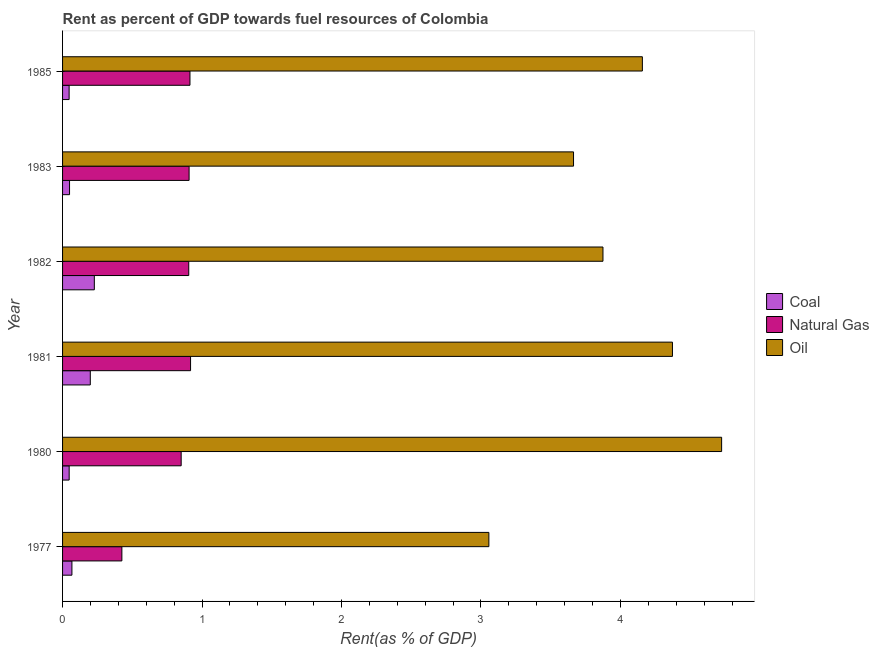How many different coloured bars are there?
Provide a short and direct response. 3. How many bars are there on the 4th tick from the top?
Keep it short and to the point. 3. In how many cases, is the number of bars for a given year not equal to the number of legend labels?
Keep it short and to the point. 0. What is the rent towards natural gas in 1981?
Provide a succinct answer. 0.92. Across all years, what is the maximum rent towards natural gas?
Your answer should be very brief. 0.92. Across all years, what is the minimum rent towards oil?
Offer a very short reply. 3.06. In which year was the rent towards oil minimum?
Provide a short and direct response. 1977. What is the total rent towards coal in the graph?
Your response must be concise. 0.64. What is the difference between the rent towards oil in 1980 and that in 1983?
Ensure brevity in your answer.  1.06. What is the difference between the rent towards oil in 1983 and the rent towards natural gas in 1980?
Offer a very short reply. 2.81. What is the average rent towards natural gas per year?
Your response must be concise. 0.82. In the year 1977, what is the difference between the rent towards oil and rent towards coal?
Provide a short and direct response. 2.99. In how many years, is the rent towards oil greater than 2.6 %?
Provide a succinct answer. 6. What is the ratio of the rent towards oil in 1981 to that in 1985?
Your answer should be compact. 1.05. Is the rent towards oil in 1983 less than that in 1985?
Give a very brief answer. Yes. What is the difference between the highest and the second highest rent towards coal?
Offer a very short reply. 0.03. What is the difference between the highest and the lowest rent towards natural gas?
Offer a very short reply. 0.49. Is the sum of the rent towards coal in 1980 and 1981 greater than the maximum rent towards natural gas across all years?
Offer a very short reply. No. What does the 1st bar from the top in 1977 represents?
Make the answer very short. Oil. What does the 1st bar from the bottom in 1980 represents?
Give a very brief answer. Coal. How many bars are there?
Your answer should be very brief. 18. Are all the bars in the graph horizontal?
Keep it short and to the point. Yes. How many years are there in the graph?
Your answer should be compact. 6. What is the difference between two consecutive major ticks on the X-axis?
Keep it short and to the point. 1. Does the graph contain grids?
Offer a very short reply. No. Where does the legend appear in the graph?
Keep it short and to the point. Center right. How many legend labels are there?
Offer a very short reply. 3. What is the title of the graph?
Your response must be concise. Rent as percent of GDP towards fuel resources of Colombia. What is the label or title of the X-axis?
Provide a succinct answer. Rent(as % of GDP). What is the Rent(as % of GDP) of Coal in 1977?
Make the answer very short. 0.07. What is the Rent(as % of GDP) in Natural Gas in 1977?
Offer a terse response. 0.43. What is the Rent(as % of GDP) of Oil in 1977?
Give a very brief answer. 3.06. What is the Rent(as % of GDP) in Coal in 1980?
Ensure brevity in your answer.  0.05. What is the Rent(as % of GDP) in Natural Gas in 1980?
Offer a terse response. 0.85. What is the Rent(as % of GDP) of Oil in 1980?
Ensure brevity in your answer.  4.73. What is the Rent(as % of GDP) of Coal in 1981?
Make the answer very short. 0.2. What is the Rent(as % of GDP) in Natural Gas in 1981?
Make the answer very short. 0.92. What is the Rent(as % of GDP) of Oil in 1981?
Make the answer very short. 4.37. What is the Rent(as % of GDP) of Coal in 1982?
Ensure brevity in your answer.  0.23. What is the Rent(as % of GDP) of Natural Gas in 1982?
Ensure brevity in your answer.  0.9. What is the Rent(as % of GDP) in Oil in 1982?
Provide a succinct answer. 3.87. What is the Rent(as % of GDP) in Coal in 1983?
Your answer should be very brief. 0.05. What is the Rent(as % of GDP) in Natural Gas in 1983?
Provide a short and direct response. 0.91. What is the Rent(as % of GDP) of Oil in 1983?
Your answer should be compact. 3.66. What is the Rent(as % of GDP) of Coal in 1985?
Make the answer very short. 0.05. What is the Rent(as % of GDP) in Natural Gas in 1985?
Ensure brevity in your answer.  0.91. What is the Rent(as % of GDP) of Oil in 1985?
Ensure brevity in your answer.  4.16. Across all years, what is the maximum Rent(as % of GDP) of Coal?
Your answer should be very brief. 0.23. Across all years, what is the maximum Rent(as % of GDP) of Natural Gas?
Your response must be concise. 0.92. Across all years, what is the maximum Rent(as % of GDP) in Oil?
Offer a terse response. 4.73. Across all years, what is the minimum Rent(as % of GDP) of Coal?
Offer a terse response. 0.05. Across all years, what is the minimum Rent(as % of GDP) in Natural Gas?
Your response must be concise. 0.43. Across all years, what is the minimum Rent(as % of GDP) in Oil?
Your response must be concise. 3.06. What is the total Rent(as % of GDP) of Coal in the graph?
Your answer should be very brief. 0.64. What is the total Rent(as % of GDP) in Natural Gas in the graph?
Your answer should be very brief. 4.92. What is the total Rent(as % of GDP) of Oil in the graph?
Offer a very short reply. 23.85. What is the difference between the Rent(as % of GDP) of Coal in 1977 and that in 1980?
Provide a succinct answer. 0.02. What is the difference between the Rent(as % of GDP) of Natural Gas in 1977 and that in 1980?
Keep it short and to the point. -0.43. What is the difference between the Rent(as % of GDP) of Oil in 1977 and that in 1980?
Provide a succinct answer. -1.67. What is the difference between the Rent(as % of GDP) in Coal in 1977 and that in 1981?
Make the answer very short. -0.13. What is the difference between the Rent(as % of GDP) in Natural Gas in 1977 and that in 1981?
Provide a succinct answer. -0.49. What is the difference between the Rent(as % of GDP) in Oil in 1977 and that in 1981?
Provide a succinct answer. -1.32. What is the difference between the Rent(as % of GDP) of Coal in 1977 and that in 1982?
Your answer should be very brief. -0.16. What is the difference between the Rent(as % of GDP) of Natural Gas in 1977 and that in 1982?
Give a very brief answer. -0.48. What is the difference between the Rent(as % of GDP) in Oil in 1977 and that in 1982?
Make the answer very short. -0.82. What is the difference between the Rent(as % of GDP) in Coal in 1977 and that in 1983?
Keep it short and to the point. 0.02. What is the difference between the Rent(as % of GDP) of Natural Gas in 1977 and that in 1983?
Ensure brevity in your answer.  -0.48. What is the difference between the Rent(as % of GDP) of Oil in 1977 and that in 1983?
Provide a succinct answer. -0.61. What is the difference between the Rent(as % of GDP) in Coal in 1977 and that in 1985?
Offer a terse response. 0.02. What is the difference between the Rent(as % of GDP) of Natural Gas in 1977 and that in 1985?
Your response must be concise. -0.49. What is the difference between the Rent(as % of GDP) in Oil in 1977 and that in 1985?
Your answer should be very brief. -1.1. What is the difference between the Rent(as % of GDP) in Coal in 1980 and that in 1981?
Provide a succinct answer. -0.15. What is the difference between the Rent(as % of GDP) of Natural Gas in 1980 and that in 1981?
Ensure brevity in your answer.  -0.07. What is the difference between the Rent(as % of GDP) in Oil in 1980 and that in 1981?
Your answer should be compact. 0.35. What is the difference between the Rent(as % of GDP) in Coal in 1980 and that in 1982?
Make the answer very short. -0.18. What is the difference between the Rent(as % of GDP) in Natural Gas in 1980 and that in 1982?
Your answer should be very brief. -0.05. What is the difference between the Rent(as % of GDP) in Oil in 1980 and that in 1982?
Your answer should be very brief. 0.85. What is the difference between the Rent(as % of GDP) of Coal in 1980 and that in 1983?
Provide a short and direct response. -0. What is the difference between the Rent(as % of GDP) in Natural Gas in 1980 and that in 1983?
Offer a terse response. -0.06. What is the difference between the Rent(as % of GDP) in Oil in 1980 and that in 1983?
Provide a short and direct response. 1.06. What is the difference between the Rent(as % of GDP) in Natural Gas in 1980 and that in 1985?
Make the answer very short. -0.06. What is the difference between the Rent(as % of GDP) in Oil in 1980 and that in 1985?
Give a very brief answer. 0.57. What is the difference between the Rent(as % of GDP) in Coal in 1981 and that in 1982?
Give a very brief answer. -0.03. What is the difference between the Rent(as % of GDP) of Natural Gas in 1981 and that in 1982?
Offer a terse response. 0.01. What is the difference between the Rent(as % of GDP) of Oil in 1981 and that in 1982?
Provide a succinct answer. 0.5. What is the difference between the Rent(as % of GDP) of Coal in 1981 and that in 1983?
Provide a short and direct response. 0.15. What is the difference between the Rent(as % of GDP) in Natural Gas in 1981 and that in 1983?
Offer a very short reply. 0.01. What is the difference between the Rent(as % of GDP) in Oil in 1981 and that in 1983?
Your response must be concise. 0.71. What is the difference between the Rent(as % of GDP) of Coal in 1981 and that in 1985?
Provide a succinct answer. 0.15. What is the difference between the Rent(as % of GDP) in Natural Gas in 1981 and that in 1985?
Provide a short and direct response. 0. What is the difference between the Rent(as % of GDP) in Oil in 1981 and that in 1985?
Offer a terse response. 0.22. What is the difference between the Rent(as % of GDP) in Coal in 1982 and that in 1983?
Provide a succinct answer. 0.18. What is the difference between the Rent(as % of GDP) of Natural Gas in 1982 and that in 1983?
Provide a short and direct response. -0. What is the difference between the Rent(as % of GDP) of Oil in 1982 and that in 1983?
Offer a very short reply. 0.21. What is the difference between the Rent(as % of GDP) of Coal in 1982 and that in 1985?
Make the answer very short. 0.18. What is the difference between the Rent(as % of GDP) in Natural Gas in 1982 and that in 1985?
Ensure brevity in your answer.  -0.01. What is the difference between the Rent(as % of GDP) of Oil in 1982 and that in 1985?
Offer a terse response. -0.28. What is the difference between the Rent(as % of GDP) in Coal in 1983 and that in 1985?
Give a very brief answer. 0. What is the difference between the Rent(as % of GDP) in Natural Gas in 1983 and that in 1985?
Provide a succinct answer. -0.01. What is the difference between the Rent(as % of GDP) of Oil in 1983 and that in 1985?
Offer a terse response. -0.49. What is the difference between the Rent(as % of GDP) in Coal in 1977 and the Rent(as % of GDP) in Natural Gas in 1980?
Give a very brief answer. -0.78. What is the difference between the Rent(as % of GDP) of Coal in 1977 and the Rent(as % of GDP) of Oil in 1980?
Make the answer very short. -4.66. What is the difference between the Rent(as % of GDP) in Natural Gas in 1977 and the Rent(as % of GDP) in Oil in 1980?
Provide a succinct answer. -4.3. What is the difference between the Rent(as % of GDP) in Coal in 1977 and the Rent(as % of GDP) in Natural Gas in 1981?
Make the answer very short. -0.85. What is the difference between the Rent(as % of GDP) in Coal in 1977 and the Rent(as % of GDP) in Oil in 1981?
Give a very brief answer. -4.31. What is the difference between the Rent(as % of GDP) of Natural Gas in 1977 and the Rent(as % of GDP) of Oil in 1981?
Keep it short and to the point. -3.95. What is the difference between the Rent(as % of GDP) in Coal in 1977 and the Rent(as % of GDP) in Natural Gas in 1982?
Ensure brevity in your answer.  -0.84. What is the difference between the Rent(as % of GDP) of Coal in 1977 and the Rent(as % of GDP) of Oil in 1982?
Your answer should be compact. -3.81. What is the difference between the Rent(as % of GDP) in Natural Gas in 1977 and the Rent(as % of GDP) in Oil in 1982?
Your response must be concise. -3.45. What is the difference between the Rent(as % of GDP) of Coal in 1977 and the Rent(as % of GDP) of Natural Gas in 1983?
Keep it short and to the point. -0.84. What is the difference between the Rent(as % of GDP) of Coal in 1977 and the Rent(as % of GDP) of Oil in 1983?
Provide a short and direct response. -3.6. What is the difference between the Rent(as % of GDP) in Natural Gas in 1977 and the Rent(as % of GDP) in Oil in 1983?
Your answer should be compact. -3.24. What is the difference between the Rent(as % of GDP) of Coal in 1977 and the Rent(as % of GDP) of Natural Gas in 1985?
Offer a terse response. -0.85. What is the difference between the Rent(as % of GDP) in Coal in 1977 and the Rent(as % of GDP) in Oil in 1985?
Offer a very short reply. -4.09. What is the difference between the Rent(as % of GDP) of Natural Gas in 1977 and the Rent(as % of GDP) of Oil in 1985?
Your answer should be compact. -3.73. What is the difference between the Rent(as % of GDP) in Coal in 1980 and the Rent(as % of GDP) in Natural Gas in 1981?
Offer a very short reply. -0.87. What is the difference between the Rent(as % of GDP) in Coal in 1980 and the Rent(as % of GDP) in Oil in 1981?
Provide a succinct answer. -4.33. What is the difference between the Rent(as % of GDP) in Natural Gas in 1980 and the Rent(as % of GDP) in Oil in 1981?
Provide a succinct answer. -3.52. What is the difference between the Rent(as % of GDP) of Coal in 1980 and the Rent(as % of GDP) of Natural Gas in 1982?
Keep it short and to the point. -0.86. What is the difference between the Rent(as % of GDP) in Coal in 1980 and the Rent(as % of GDP) in Oil in 1982?
Give a very brief answer. -3.83. What is the difference between the Rent(as % of GDP) in Natural Gas in 1980 and the Rent(as % of GDP) in Oil in 1982?
Offer a terse response. -3.02. What is the difference between the Rent(as % of GDP) of Coal in 1980 and the Rent(as % of GDP) of Natural Gas in 1983?
Offer a very short reply. -0.86. What is the difference between the Rent(as % of GDP) of Coal in 1980 and the Rent(as % of GDP) of Oil in 1983?
Keep it short and to the point. -3.62. What is the difference between the Rent(as % of GDP) of Natural Gas in 1980 and the Rent(as % of GDP) of Oil in 1983?
Keep it short and to the point. -2.81. What is the difference between the Rent(as % of GDP) in Coal in 1980 and the Rent(as % of GDP) in Natural Gas in 1985?
Provide a succinct answer. -0.87. What is the difference between the Rent(as % of GDP) in Coal in 1980 and the Rent(as % of GDP) in Oil in 1985?
Your answer should be compact. -4.11. What is the difference between the Rent(as % of GDP) in Natural Gas in 1980 and the Rent(as % of GDP) in Oil in 1985?
Make the answer very short. -3.31. What is the difference between the Rent(as % of GDP) in Coal in 1981 and the Rent(as % of GDP) in Natural Gas in 1982?
Your answer should be very brief. -0.71. What is the difference between the Rent(as % of GDP) of Coal in 1981 and the Rent(as % of GDP) of Oil in 1982?
Ensure brevity in your answer.  -3.68. What is the difference between the Rent(as % of GDP) of Natural Gas in 1981 and the Rent(as % of GDP) of Oil in 1982?
Give a very brief answer. -2.96. What is the difference between the Rent(as % of GDP) in Coal in 1981 and the Rent(as % of GDP) in Natural Gas in 1983?
Make the answer very short. -0.71. What is the difference between the Rent(as % of GDP) of Coal in 1981 and the Rent(as % of GDP) of Oil in 1983?
Provide a short and direct response. -3.46. What is the difference between the Rent(as % of GDP) of Natural Gas in 1981 and the Rent(as % of GDP) of Oil in 1983?
Your response must be concise. -2.75. What is the difference between the Rent(as % of GDP) in Coal in 1981 and the Rent(as % of GDP) in Natural Gas in 1985?
Your answer should be very brief. -0.71. What is the difference between the Rent(as % of GDP) in Coal in 1981 and the Rent(as % of GDP) in Oil in 1985?
Offer a very short reply. -3.96. What is the difference between the Rent(as % of GDP) of Natural Gas in 1981 and the Rent(as % of GDP) of Oil in 1985?
Your answer should be very brief. -3.24. What is the difference between the Rent(as % of GDP) of Coal in 1982 and the Rent(as % of GDP) of Natural Gas in 1983?
Ensure brevity in your answer.  -0.68. What is the difference between the Rent(as % of GDP) of Coal in 1982 and the Rent(as % of GDP) of Oil in 1983?
Provide a short and direct response. -3.44. What is the difference between the Rent(as % of GDP) of Natural Gas in 1982 and the Rent(as % of GDP) of Oil in 1983?
Your answer should be compact. -2.76. What is the difference between the Rent(as % of GDP) in Coal in 1982 and the Rent(as % of GDP) in Natural Gas in 1985?
Provide a short and direct response. -0.69. What is the difference between the Rent(as % of GDP) in Coal in 1982 and the Rent(as % of GDP) in Oil in 1985?
Provide a succinct answer. -3.93. What is the difference between the Rent(as % of GDP) in Natural Gas in 1982 and the Rent(as % of GDP) in Oil in 1985?
Provide a short and direct response. -3.25. What is the difference between the Rent(as % of GDP) in Coal in 1983 and the Rent(as % of GDP) in Natural Gas in 1985?
Provide a short and direct response. -0.86. What is the difference between the Rent(as % of GDP) in Coal in 1983 and the Rent(as % of GDP) in Oil in 1985?
Make the answer very short. -4.11. What is the difference between the Rent(as % of GDP) in Natural Gas in 1983 and the Rent(as % of GDP) in Oil in 1985?
Keep it short and to the point. -3.25. What is the average Rent(as % of GDP) in Coal per year?
Offer a terse response. 0.11. What is the average Rent(as % of GDP) in Natural Gas per year?
Keep it short and to the point. 0.82. What is the average Rent(as % of GDP) of Oil per year?
Ensure brevity in your answer.  3.98. In the year 1977, what is the difference between the Rent(as % of GDP) of Coal and Rent(as % of GDP) of Natural Gas?
Your answer should be very brief. -0.36. In the year 1977, what is the difference between the Rent(as % of GDP) of Coal and Rent(as % of GDP) of Oil?
Your answer should be compact. -2.99. In the year 1977, what is the difference between the Rent(as % of GDP) of Natural Gas and Rent(as % of GDP) of Oil?
Make the answer very short. -2.63. In the year 1980, what is the difference between the Rent(as % of GDP) of Coal and Rent(as % of GDP) of Natural Gas?
Provide a short and direct response. -0.8. In the year 1980, what is the difference between the Rent(as % of GDP) in Coal and Rent(as % of GDP) in Oil?
Give a very brief answer. -4.68. In the year 1980, what is the difference between the Rent(as % of GDP) of Natural Gas and Rent(as % of GDP) of Oil?
Your answer should be compact. -3.88. In the year 1981, what is the difference between the Rent(as % of GDP) of Coal and Rent(as % of GDP) of Natural Gas?
Your answer should be very brief. -0.72. In the year 1981, what is the difference between the Rent(as % of GDP) in Coal and Rent(as % of GDP) in Oil?
Make the answer very short. -4.17. In the year 1981, what is the difference between the Rent(as % of GDP) in Natural Gas and Rent(as % of GDP) in Oil?
Ensure brevity in your answer.  -3.46. In the year 1982, what is the difference between the Rent(as % of GDP) in Coal and Rent(as % of GDP) in Natural Gas?
Make the answer very short. -0.68. In the year 1982, what is the difference between the Rent(as % of GDP) in Coal and Rent(as % of GDP) in Oil?
Offer a very short reply. -3.65. In the year 1982, what is the difference between the Rent(as % of GDP) of Natural Gas and Rent(as % of GDP) of Oil?
Ensure brevity in your answer.  -2.97. In the year 1983, what is the difference between the Rent(as % of GDP) of Coal and Rent(as % of GDP) of Natural Gas?
Offer a terse response. -0.86. In the year 1983, what is the difference between the Rent(as % of GDP) of Coal and Rent(as % of GDP) of Oil?
Offer a very short reply. -3.61. In the year 1983, what is the difference between the Rent(as % of GDP) in Natural Gas and Rent(as % of GDP) in Oil?
Your answer should be compact. -2.76. In the year 1985, what is the difference between the Rent(as % of GDP) in Coal and Rent(as % of GDP) in Natural Gas?
Make the answer very short. -0.87. In the year 1985, what is the difference between the Rent(as % of GDP) in Coal and Rent(as % of GDP) in Oil?
Offer a very short reply. -4.11. In the year 1985, what is the difference between the Rent(as % of GDP) of Natural Gas and Rent(as % of GDP) of Oil?
Your answer should be compact. -3.24. What is the ratio of the Rent(as % of GDP) of Coal in 1977 to that in 1980?
Your answer should be compact. 1.42. What is the ratio of the Rent(as % of GDP) of Natural Gas in 1977 to that in 1980?
Your answer should be very brief. 0.5. What is the ratio of the Rent(as % of GDP) of Oil in 1977 to that in 1980?
Provide a succinct answer. 0.65. What is the ratio of the Rent(as % of GDP) in Coal in 1977 to that in 1981?
Give a very brief answer. 0.34. What is the ratio of the Rent(as % of GDP) in Natural Gas in 1977 to that in 1981?
Provide a succinct answer. 0.46. What is the ratio of the Rent(as % of GDP) in Oil in 1977 to that in 1981?
Keep it short and to the point. 0.7. What is the ratio of the Rent(as % of GDP) of Coal in 1977 to that in 1982?
Your answer should be compact. 0.29. What is the ratio of the Rent(as % of GDP) of Natural Gas in 1977 to that in 1982?
Offer a very short reply. 0.47. What is the ratio of the Rent(as % of GDP) of Oil in 1977 to that in 1982?
Provide a succinct answer. 0.79. What is the ratio of the Rent(as % of GDP) of Coal in 1977 to that in 1983?
Offer a very short reply. 1.34. What is the ratio of the Rent(as % of GDP) in Natural Gas in 1977 to that in 1983?
Ensure brevity in your answer.  0.47. What is the ratio of the Rent(as % of GDP) in Oil in 1977 to that in 1983?
Your response must be concise. 0.83. What is the ratio of the Rent(as % of GDP) in Coal in 1977 to that in 1985?
Your answer should be very brief. 1.43. What is the ratio of the Rent(as % of GDP) in Natural Gas in 1977 to that in 1985?
Your response must be concise. 0.47. What is the ratio of the Rent(as % of GDP) in Oil in 1977 to that in 1985?
Keep it short and to the point. 0.74. What is the ratio of the Rent(as % of GDP) of Coal in 1980 to that in 1981?
Keep it short and to the point. 0.24. What is the ratio of the Rent(as % of GDP) of Natural Gas in 1980 to that in 1981?
Provide a succinct answer. 0.93. What is the ratio of the Rent(as % of GDP) of Oil in 1980 to that in 1981?
Provide a succinct answer. 1.08. What is the ratio of the Rent(as % of GDP) in Coal in 1980 to that in 1982?
Provide a short and direct response. 0.21. What is the ratio of the Rent(as % of GDP) in Natural Gas in 1980 to that in 1982?
Offer a very short reply. 0.94. What is the ratio of the Rent(as % of GDP) of Oil in 1980 to that in 1982?
Your answer should be compact. 1.22. What is the ratio of the Rent(as % of GDP) of Coal in 1980 to that in 1983?
Make the answer very short. 0.95. What is the ratio of the Rent(as % of GDP) of Natural Gas in 1980 to that in 1983?
Offer a very short reply. 0.94. What is the ratio of the Rent(as % of GDP) in Oil in 1980 to that in 1983?
Provide a short and direct response. 1.29. What is the ratio of the Rent(as % of GDP) of Natural Gas in 1980 to that in 1985?
Make the answer very short. 0.93. What is the ratio of the Rent(as % of GDP) of Oil in 1980 to that in 1985?
Ensure brevity in your answer.  1.14. What is the ratio of the Rent(as % of GDP) of Coal in 1981 to that in 1982?
Your answer should be compact. 0.87. What is the ratio of the Rent(as % of GDP) in Natural Gas in 1981 to that in 1982?
Offer a terse response. 1.01. What is the ratio of the Rent(as % of GDP) of Oil in 1981 to that in 1982?
Keep it short and to the point. 1.13. What is the ratio of the Rent(as % of GDP) of Coal in 1981 to that in 1983?
Your answer should be compact. 3.98. What is the ratio of the Rent(as % of GDP) in Natural Gas in 1981 to that in 1983?
Offer a terse response. 1.01. What is the ratio of the Rent(as % of GDP) in Oil in 1981 to that in 1983?
Your answer should be very brief. 1.19. What is the ratio of the Rent(as % of GDP) of Coal in 1981 to that in 1985?
Make the answer very short. 4.23. What is the ratio of the Rent(as % of GDP) of Natural Gas in 1981 to that in 1985?
Ensure brevity in your answer.  1. What is the ratio of the Rent(as % of GDP) of Oil in 1981 to that in 1985?
Provide a succinct answer. 1.05. What is the ratio of the Rent(as % of GDP) in Coal in 1982 to that in 1983?
Your answer should be very brief. 4.55. What is the ratio of the Rent(as % of GDP) in Oil in 1982 to that in 1983?
Your response must be concise. 1.06. What is the ratio of the Rent(as % of GDP) in Coal in 1982 to that in 1985?
Your answer should be very brief. 4.84. What is the ratio of the Rent(as % of GDP) in Natural Gas in 1982 to that in 1985?
Provide a succinct answer. 0.99. What is the ratio of the Rent(as % of GDP) in Oil in 1982 to that in 1985?
Offer a terse response. 0.93. What is the ratio of the Rent(as % of GDP) of Coal in 1983 to that in 1985?
Offer a terse response. 1.06. What is the ratio of the Rent(as % of GDP) in Natural Gas in 1983 to that in 1985?
Your response must be concise. 0.99. What is the ratio of the Rent(as % of GDP) in Oil in 1983 to that in 1985?
Provide a succinct answer. 0.88. What is the difference between the highest and the second highest Rent(as % of GDP) in Coal?
Provide a succinct answer. 0.03. What is the difference between the highest and the second highest Rent(as % of GDP) of Natural Gas?
Keep it short and to the point. 0. What is the difference between the highest and the second highest Rent(as % of GDP) in Oil?
Keep it short and to the point. 0.35. What is the difference between the highest and the lowest Rent(as % of GDP) in Coal?
Ensure brevity in your answer.  0.18. What is the difference between the highest and the lowest Rent(as % of GDP) in Natural Gas?
Your response must be concise. 0.49. What is the difference between the highest and the lowest Rent(as % of GDP) of Oil?
Your answer should be very brief. 1.67. 